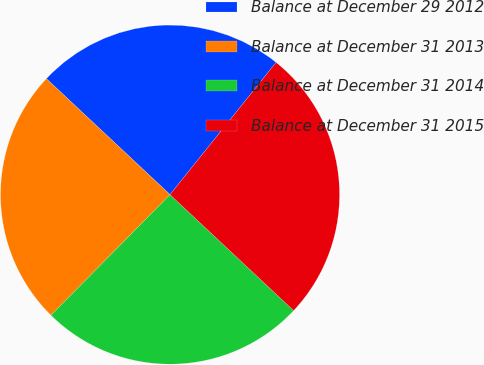Convert chart to OTSL. <chart><loc_0><loc_0><loc_500><loc_500><pie_chart><fcel>Balance at December 29 2012<fcel>Balance at December 31 2013<fcel>Balance at December 31 2014<fcel>Balance at December 31 2015<nl><fcel>23.77%<fcel>24.59%<fcel>25.41%<fcel>26.23%<nl></chart> 